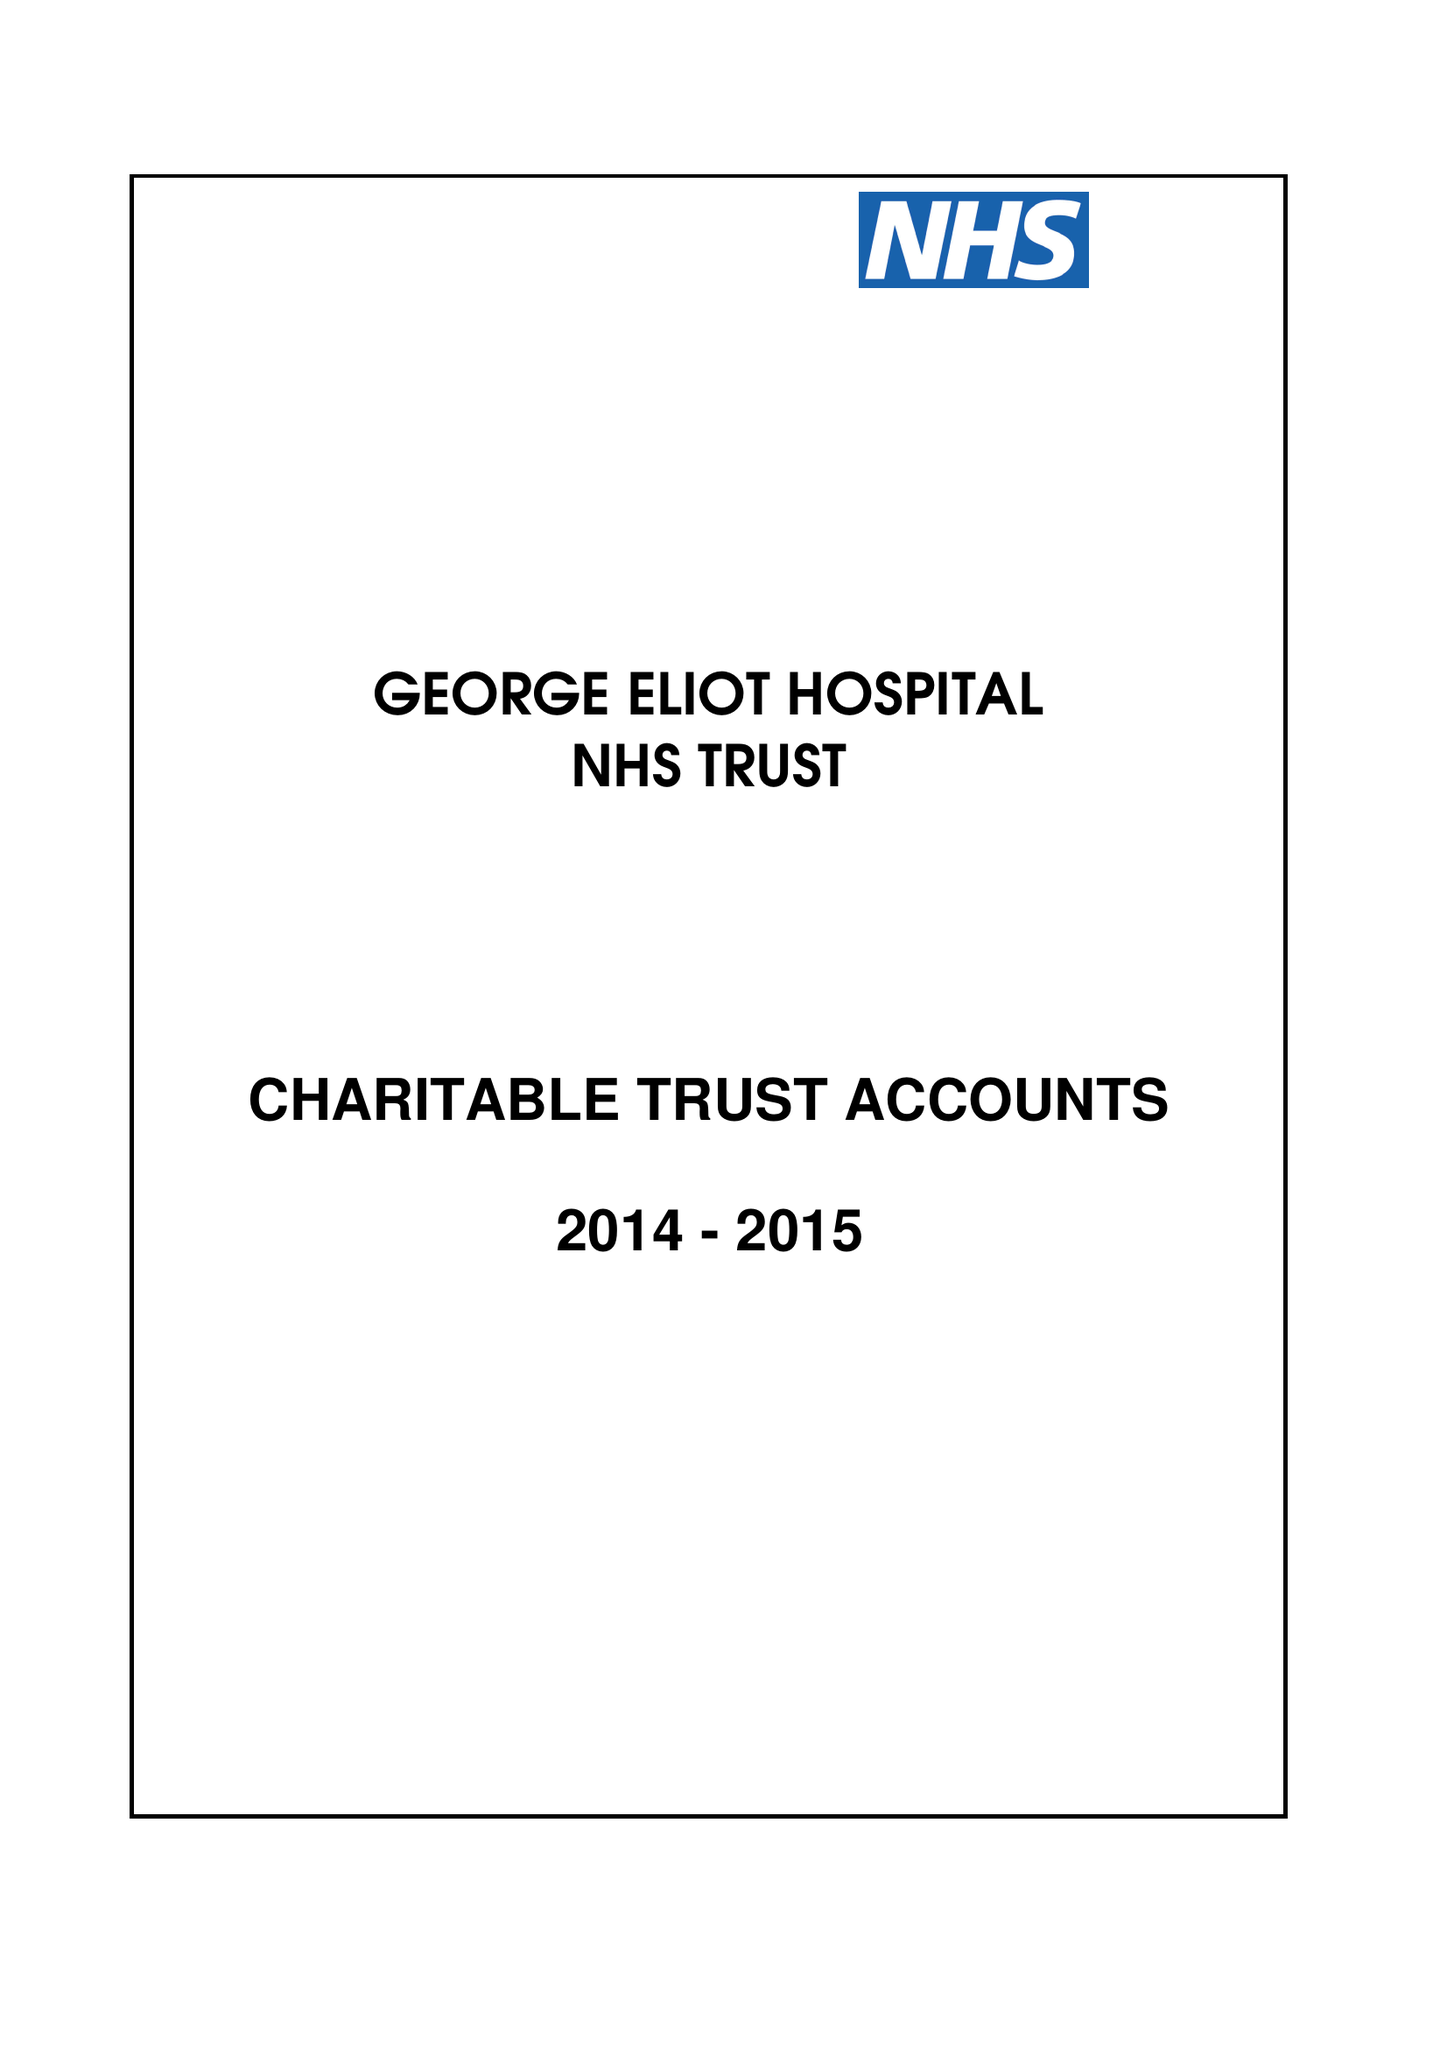What is the value for the charity_name?
Answer the question using a single word or phrase. George Eliot Hospital Nhs Trust Charitable Fund and Other Related Charities 